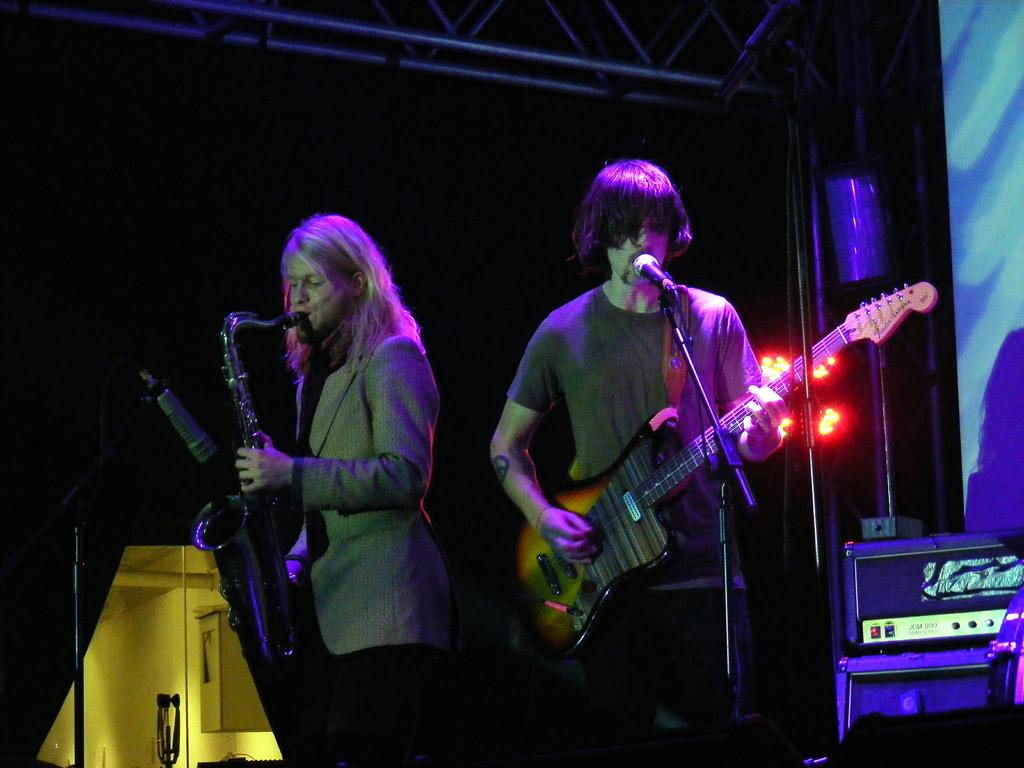How many people are in the image? There are two men in the image. What are the men holding in the image? Both men are holding musical instruments. What can be seen in front of the men? The men are standing in front of a microphone. What is visible in the background of the image? There are lights and equipment visible in the background. What type of bit is being used by the men in the image? There is no bit present in the image; the men are holding musical instruments. Can you tell me how many pails are visible in the image? There are no pails visible in the image. 